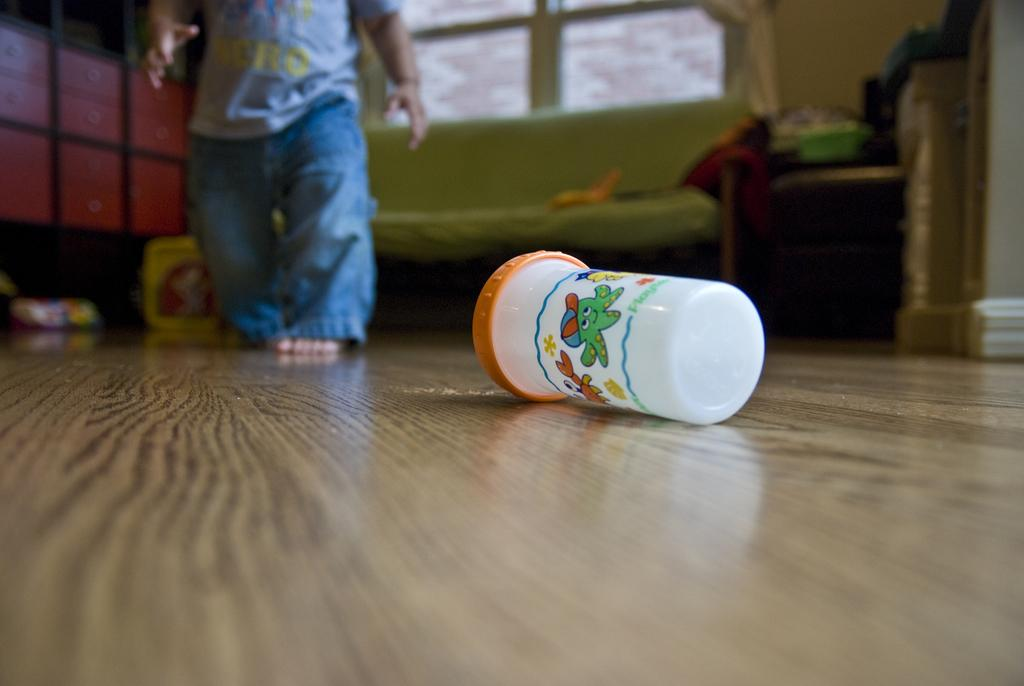What is the main subject of the image? There is a kid in the image. What can be seen on the floor in the image? There is a box on the floor in the image. What is visible in the background of the image? There is a wall, a window, a bed, a table, and shelves in the background of the image. Can you describe the setting where the image might have been taken? The image may have been taken in a hall, based on the presence of various furniture and objects. What type of wilderness can be seen through the window in the image? There is no wilderness visible through the window in the image; it is a window in a room with various furniture and objects. How many pages are visible in the image? There are no pages present in the image. 